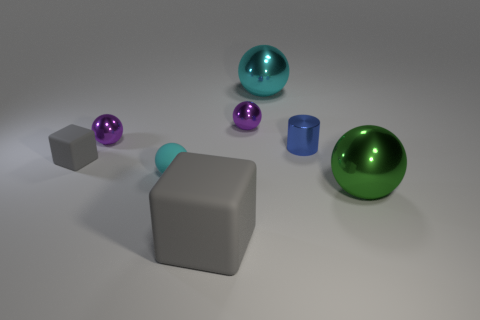Subtract all green spheres. How many spheres are left? 4 Subtract all small rubber balls. How many balls are left? 4 Subtract all gray balls. Subtract all green cubes. How many balls are left? 5 Add 1 big green objects. How many objects exist? 9 Subtract all cylinders. How many objects are left? 7 Add 2 big brown balls. How many big brown balls exist? 2 Subtract 0 blue spheres. How many objects are left? 8 Subtract all tiny things. Subtract all small gray objects. How many objects are left? 2 Add 2 small objects. How many small objects are left? 7 